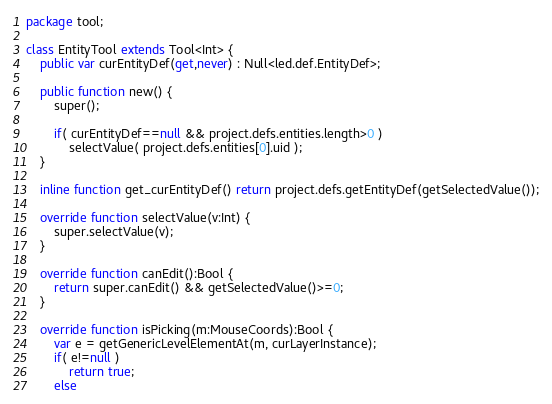Convert code to text. <code><loc_0><loc_0><loc_500><loc_500><_Haxe_>package tool;

class EntityTool extends Tool<Int> {
	public var curEntityDef(get,never) : Null<led.def.EntityDef>;

	public function new() {
		super();

		if( curEntityDef==null && project.defs.entities.length>0 )
			selectValue( project.defs.entities[0].uid );
	}

	inline function get_curEntityDef() return project.defs.getEntityDef(getSelectedValue());

	override function selectValue(v:Int) {
		super.selectValue(v);
	}

	override function canEdit():Bool {
		return super.canEdit() && getSelectedValue()>=0;
	}

	override function isPicking(m:MouseCoords):Bool {
		var e = getGenericLevelElementAt(m, curLayerInstance);
		if( e!=null )
			return true;
		else</code> 